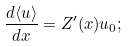Convert formula to latex. <formula><loc_0><loc_0><loc_500><loc_500>\frac { d \langle u \rangle } { d x } = { Z } ^ { \prime } ( x ) u _ { 0 } ;</formula> 